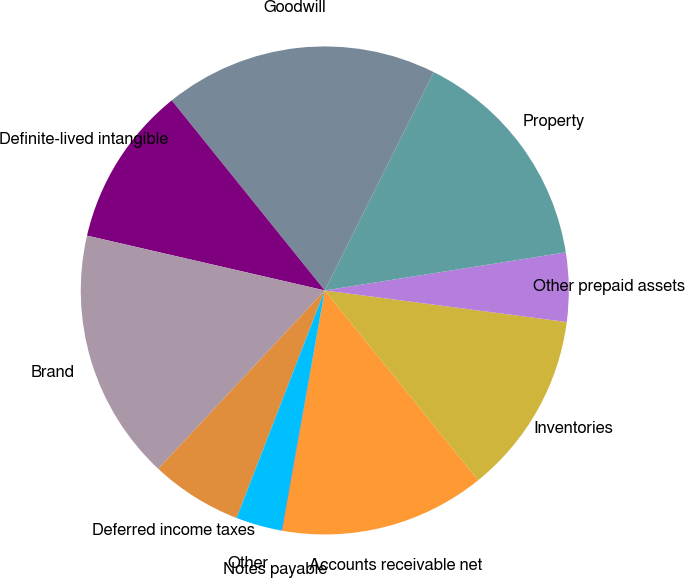Convert chart. <chart><loc_0><loc_0><loc_500><loc_500><pie_chart><fcel>Accounts receivable net<fcel>Inventories<fcel>Other prepaid assets<fcel>Property<fcel>Goodwill<fcel>Definite-lived intangible<fcel>Brand<fcel>Deferred income taxes<fcel>Other<fcel>Notes payable<nl><fcel>13.62%<fcel>12.11%<fcel>4.56%<fcel>15.13%<fcel>18.15%<fcel>10.6%<fcel>16.64%<fcel>6.07%<fcel>3.05%<fcel>0.03%<nl></chart> 